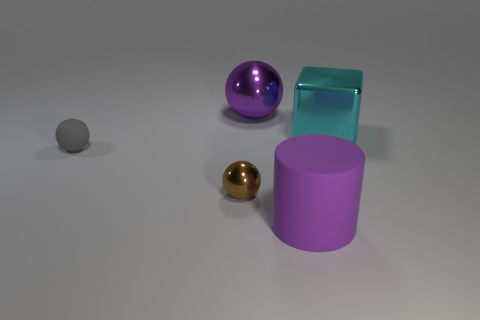Imagine these objects are part of a story. Can you create a narrative involving them? In a realm where objects symbolize the elements, the reflective gold sphere stands for the sun, bringer of warmth and light. The purple cylinder, with its matte surface, represents the Earth, grounded and constant. The large shiny sphere is the moon, reflecting the sun’s light in the night, and the semi-transparent cuboid is water, essential and life-giving. The story unfolds as they harmoniously sustain the balance of this mystical world. 